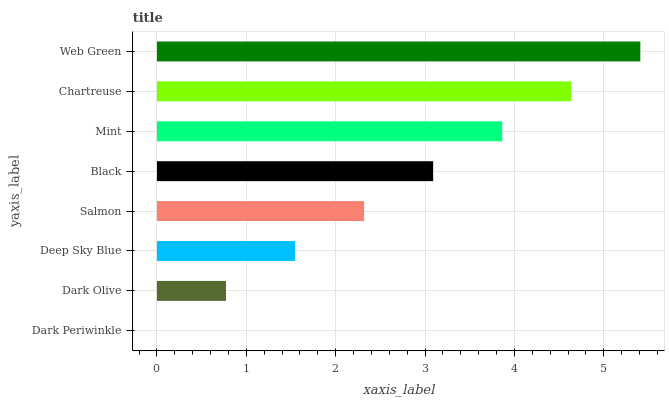Is Dark Periwinkle the minimum?
Answer yes or no. Yes. Is Web Green the maximum?
Answer yes or no. Yes. Is Dark Olive the minimum?
Answer yes or no. No. Is Dark Olive the maximum?
Answer yes or no. No. Is Dark Olive greater than Dark Periwinkle?
Answer yes or no. Yes. Is Dark Periwinkle less than Dark Olive?
Answer yes or no. Yes. Is Dark Periwinkle greater than Dark Olive?
Answer yes or no. No. Is Dark Olive less than Dark Periwinkle?
Answer yes or no. No. Is Black the high median?
Answer yes or no. Yes. Is Salmon the low median?
Answer yes or no. Yes. Is Dark Periwinkle the high median?
Answer yes or no. No. Is Dark Olive the low median?
Answer yes or no. No. 